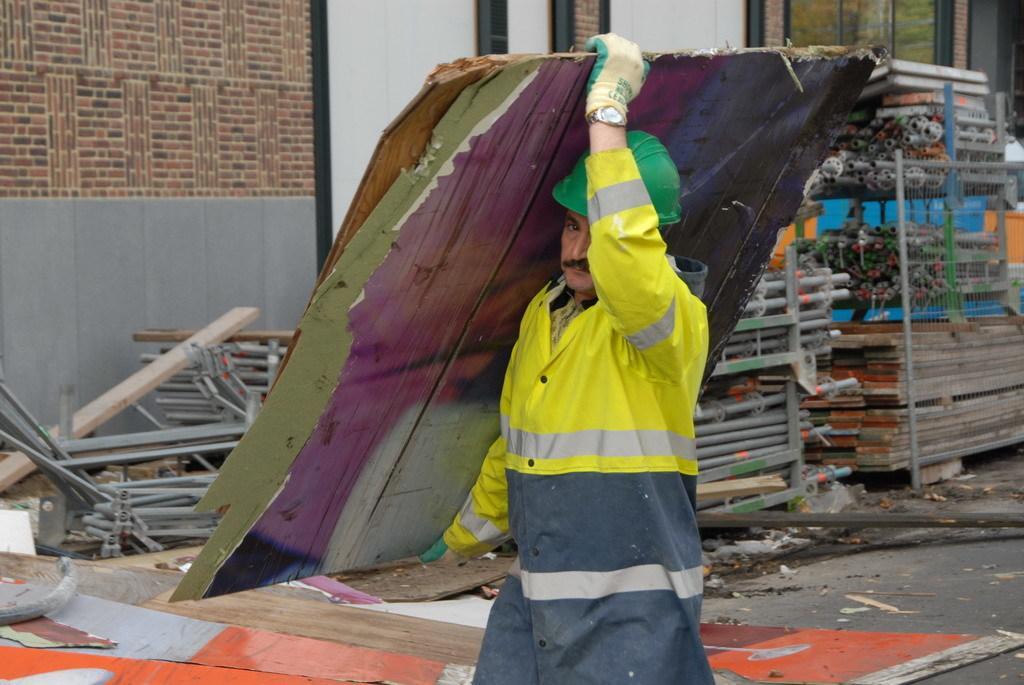How would you summarize this image in a sentence or two? In this picture I can see there is a man holding wooden planks and there are few iron frames in the backdrop and wooden planks, there is a window and there is a brick wall. 